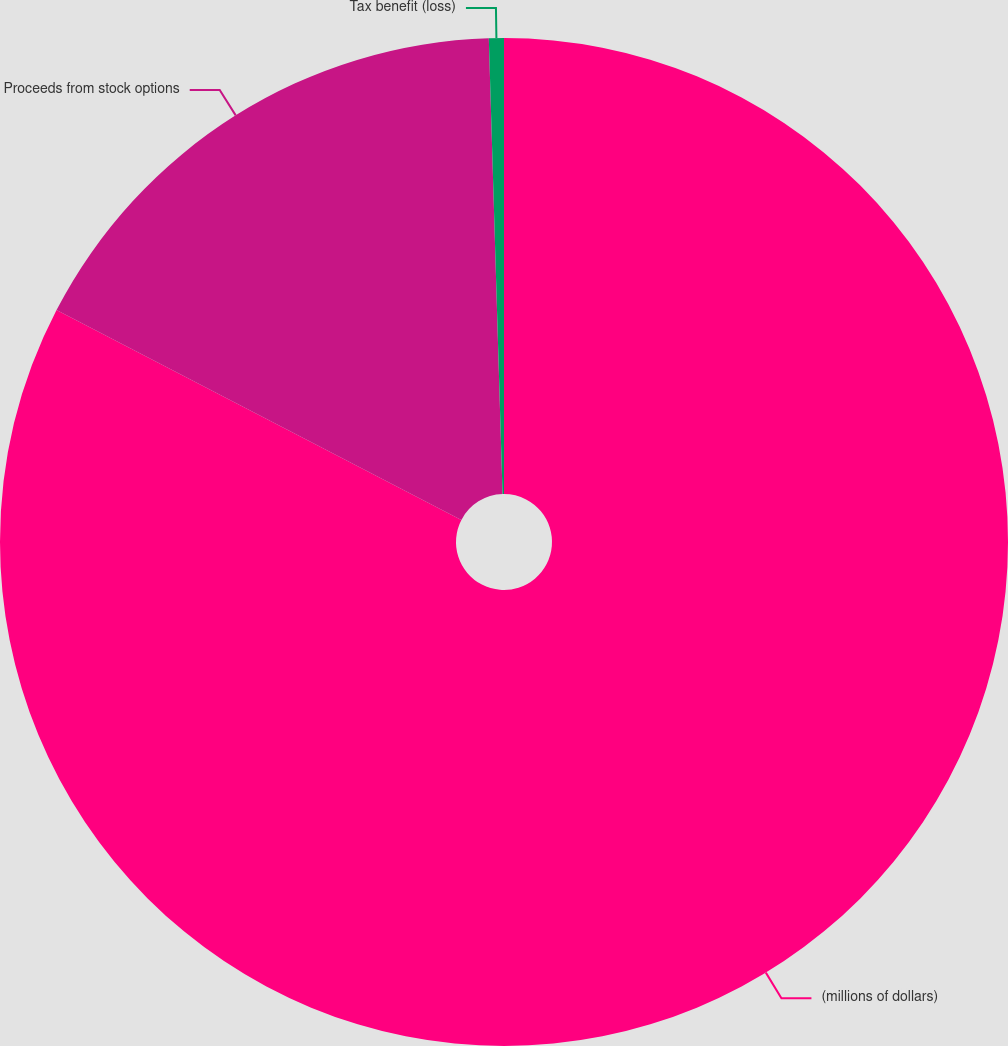Convert chart to OTSL. <chart><loc_0><loc_0><loc_500><loc_500><pie_chart><fcel>(millions of dollars)<fcel>Proceeds from stock options<fcel>Tax benefit (loss)<nl><fcel>82.61%<fcel>16.91%<fcel>0.48%<nl></chart> 